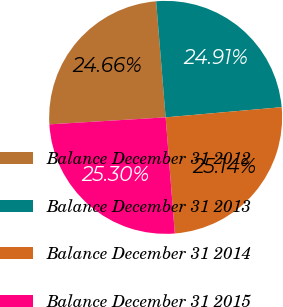<chart> <loc_0><loc_0><loc_500><loc_500><pie_chart><fcel>Balance December 31 2012<fcel>Balance December 31 2013<fcel>Balance December 31 2014<fcel>Balance December 31 2015<nl><fcel>24.66%<fcel>24.91%<fcel>25.14%<fcel>25.3%<nl></chart> 